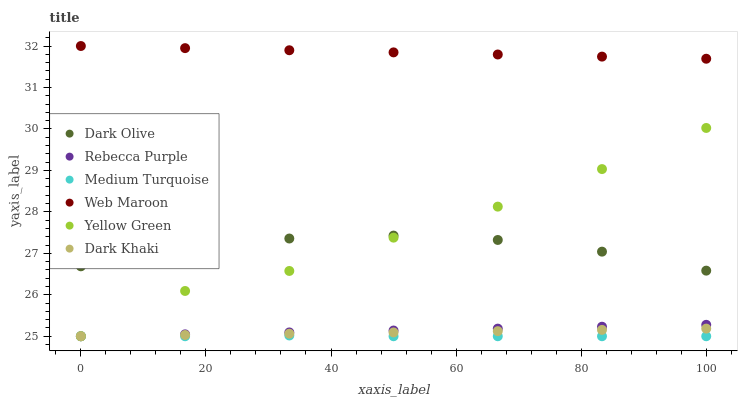Does Medium Turquoise have the minimum area under the curve?
Answer yes or no. Yes. Does Web Maroon have the maximum area under the curve?
Answer yes or no. Yes. Does Dark Olive have the minimum area under the curve?
Answer yes or no. No. Does Dark Olive have the maximum area under the curve?
Answer yes or no. No. Is Dark Khaki the smoothest?
Answer yes or no. Yes. Is Yellow Green the roughest?
Answer yes or no. Yes. Is Dark Olive the smoothest?
Answer yes or no. No. Is Dark Olive the roughest?
Answer yes or no. No. Does Yellow Green have the lowest value?
Answer yes or no. Yes. Does Dark Olive have the lowest value?
Answer yes or no. No. Does Web Maroon have the highest value?
Answer yes or no. Yes. Does Dark Olive have the highest value?
Answer yes or no. No. Is Dark Olive less than Web Maroon?
Answer yes or no. Yes. Is Web Maroon greater than Dark Khaki?
Answer yes or no. Yes. Does Medium Turquoise intersect Dark Khaki?
Answer yes or no. Yes. Is Medium Turquoise less than Dark Khaki?
Answer yes or no. No. Is Medium Turquoise greater than Dark Khaki?
Answer yes or no. No. Does Dark Olive intersect Web Maroon?
Answer yes or no. No. 